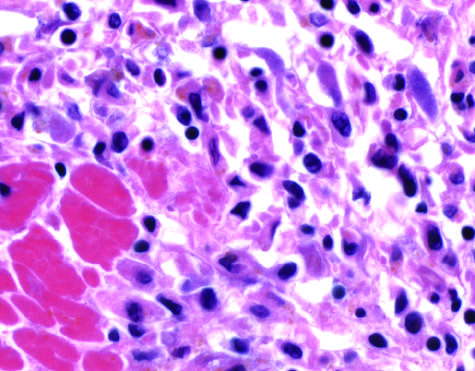what do the photomicrographs show in the myocardium after ischemic necrosis infarction?
Answer the question using a single word or phrase. An inflammatory reaction 